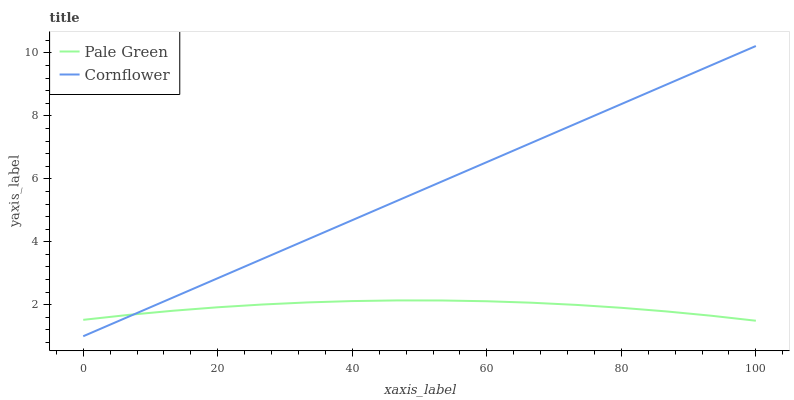Does Pale Green have the minimum area under the curve?
Answer yes or no. Yes. Does Cornflower have the maximum area under the curve?
Answer yes or no. Yes. Does Pale Green have the maximum area under the curve?
Answer yes or no. No. Is Cornflower the smoothest?
Answer yes or no. Yes. Is Pale Green the roughest?
Answer yes or no. Yes. Is Pale Green the smoothest?
Answer yes or no. No. Does Cornflower have the lowest value?
Answer yes or no. Yes. Does Pale Green have the lowest value?
Answer yes or no. No. Does Cornflower have the highest value?
Answer yes or no. Yes. Does Pale Green have the highest value?
Answer yes or no. No. Does Pale Green intersect Cornflower?
Answer yes or no. Yes. Is Pale Green less than Cornflower?
Answer yes or no. No. Is Pale Green greater than Cornflower?
Answer yes or no. No. 